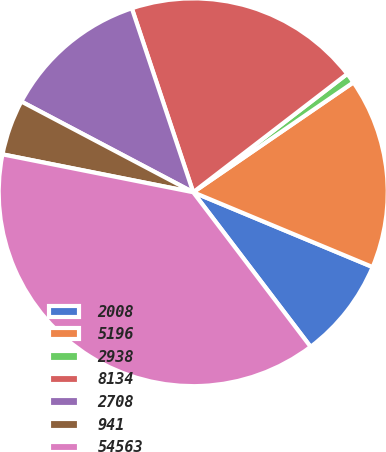<chart> <loc_0><loc_0><loc_500><loc_500><pie_chart><fcel>2008<fcel>5196<fcel>2938<fcel>8134<fcel>2708<fcel>941<fcel>54563<nl><fcel>8.38%<fcel>15.9%<fcel>0.86%<fcel>19.66%<fcel>12.14%<fcel>4.62%<fcel>38.45%<nl></chart> 